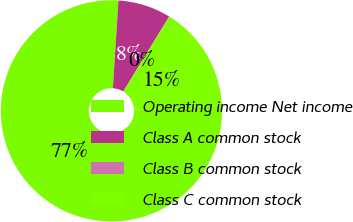Convert chart. <chart><loc_0><loc_0><loc_500><loc_500><pie_chart><fcel>Operating income Net income<fcel>Class A common stock<fcel>Class B common stock<fcel>Class C common stock<nl><fcel>76.82%<fcel>7.73%<fcel>0.05%<fcel>15.4%<nl></chart> 